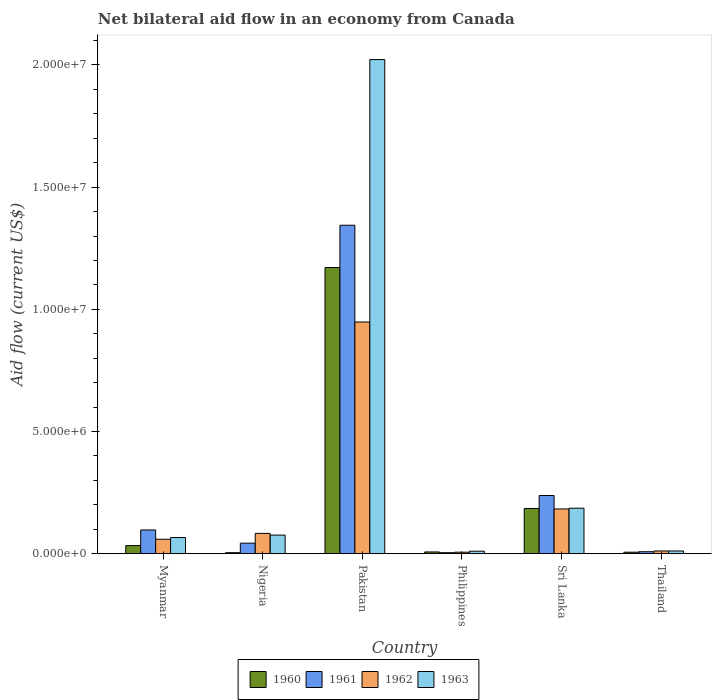How many groups of bars are there?
Make the answer very short. 6. How many bars are there on the 2nd tick from the left?
Make the answer very short. 4. What is the label of the 5th group of bars from the left?
Offer a terse response. Sri Lanka. Across all countries, what is the maximum net bilateral aid flow in 1960?
Your response must be concise. 1.17e+07. What is the total net bilateral aid flow in 1963 in the graph?
Your answer should be very brief. 2.37e+07. What is the difference between the net bilateral aid flow in 1961 in Nigeria and the net bilateral aid flow in 1962 in Sri Lanka?
Offer a terse response. -1.40e+06. What is the average net bilateral aid flow in 1960 per country?
Ensure brevity in your answer.  2.34e+06. What is the difference between the net bilateral aid flow of/in 1962 and net bilateral aid flow of/in 1960 in Philippines?
Provide a short and direct response. -10000. In how many countries, is the net bilateral aid flow in 1963 greater than 10000000 US$?
Keep it short and to the point. 1. What is the ratio of the net bilateral aid flow in 1962 in Nigeria to that in Sri Lanka?
Your answer should be very brief. 0.45. Is the net bilateral aid flow in 1963 in Philippines less than that in Thailand?
Your answer should be very brief. Yes. What is the difference between the highest and the second highest net bilateral aid flow in 1960?
Ensure brevity in your answer.  1.14e+07. What is the difference between the highest and the lowest net bilateral aid flow in 1963?
Provide a short and direct response. 2.01e+07. In how many countries, is the net bilateral aid flow in 1961 greater than the average net bilateral aid flow in 1961 taken over all countries?
Offer a terse response. 1. Is it the case that in every country, the sum of the net bilateral aid flow in 1961 and net bilateral aid flow in 1962 is greater than the sum of net bilateral aid flow in 1963 and net bilateral aid flow in 1960?
Your response must be concise. No. Are all the bars in the graph horizontal?
Provide a succinct answer. No. How many countries are there in the graph?
Give a very brief answer. 6. Are the values on the major ticks of Y-axis written in scientific E-notation?
Offer a terse response. Yes. Does the graph contain any zero values?
Offer a very short reply. No. Does the graph contain grids?
Your answer should be very brief. No. Where does the legend appear in the graph?
Offer a terse response. Bottom center. What is the title of the graph?
Your response must be concise. Net bilateral aid flow in an economy from Canada. Does "1972" appear as one of the legend labels in the graph?
Provide a succinct answer. No. What is the label or title of the X-axis?
Provide a short and direct response. Country. What is the Aid flow (current US$) in 1960 in Myanmar?
Offer a terse response. 3.30e+05. What is the Aid flow (current US$) in 1961 in Myanmar?
Your response must be concise. 9.70e+05. What is the Aid flow (current US$) in 1962 in Myanmar?
Provide a succinct answer. 5.90e+05. What is the Aid flow (current US$) of 1960 in Nigeria?
Keep it short and to the point. 4.00e+04. What is the Aid flow (current US$) in 1962 in Nigeria?
Your response must be concise. 8.30e+05. What is the Aid flow (current US$) in 1963 in Nigeria?
Make the answer very short. 7.60e+05. What is the Aid flow (current US$) of 1960 in Pakistan?
Offer a very short reply. 1.17e+07. What is the Aid flow (current US$) in 1961 in Pakistan?
Keep it short and to the point. 1.34e+07. What is the Aid flow (current US$) of 1962 in Pakistan?
Offer a terse response. 9.48e+06. What is the Aid flow (current US$) in 1963 in Pakistan?
Keep it short and to the point. 2.02e+07. What is the Aid flow (current US$) in 1961 in Philippines?
Give a very brief answer. 4.00e+04. What is the Aid flow (current US$) in 1960 in Sri Lanka?
Offer a very short reply. 1.85e+06. What is the Aid flow (current US$) of 1961 in Sri Lanka?
Your answer should be very brief. 2.38e+06. What is the Aid flow (current US$) in 1962 in Sri Lanka?
Offer a terse response. 1.83e+06. What is the Aid flow (current US$) of 1963 in Sri Lanka?
Give a very brief answer. 1.86e+06. What is the Aid flow (current US$) in 1960 in Thailand?
Ensure brevity in your answer.  6.00e+04. What is the Aid flow (current US$) in 1963 in Thailand?
Offer a very short reply. 1.10e+05. Across all countries, what is the maximum Aid flow (current US$) in 1960?
Offer a terse response. 1.17e+07. Across all countries, what is the maximum Aid flow (current US$) of 1961?
Offer a terse response. 1.34e+07. Across all countries, what is the maximum Aid flow (current US$) in 1962?
Your answer should be compact. 9.48e+06. Across all countries, what is the maximum Aid flow (current US$) of 1963?
Provide a short and direct response. 2.02e+07. Across all countries, what is the minimum Aid flow (current US$) in 1962?
Offer a terse response. 6.00e+04. Across all countries, what is the minimum Aid flow (current US$) of 1963?
Make the answer very short. 1.00e+05. What is the total Aid flow (current US$) in 1960 in the graph?
Provide a short and direct response. 1.41e+07. What is the total Aid flow (current US$) in 1961 in the graph?
Keep it short and to the point. 1.73e+07. What is the total Aid flow (current US$) of 1962 in the graph?
Ensure brevity in your answer.  1.29e+07. What is the total Aid flow (current US$) in 1963 in the graph?
Offer a terse response. 2.37e+07. What is the difference between the Aid flow (current US$) in 1961 in Myanmar and that in Nigeria?
Give a very brief answer. 5.40e+05. What is the difference between the Aid flow (current US$) in 1960 in Myanmar and that in Pakistan?
Your answer should be compact. -1.14e+07. What is the difference between the Aid flow (current US$) in 1961 in Myanmar and that in Pakistan?
Make the answer very short. -1.25e+07. What is the difference between the Aid flow (current US$) of 1962 in Myanmar and that in Pakistan?
Your answer should be compact. -8.89e+06. What is the difference between the Aid flow (current US$) of 1963 in Myanmar and that in Pakistan?
Give a very brief answer. -1.96e+07. What is the difference between the Aid flow (current US$) in 1960 in Myanmar and that in Philippines?
Give a very brief answer. 2.60e+05. What is the difference between the Aid flow (current US$) of 1961 in Myanmar and that in Philippines?
Ensure brevity in your answer.  9.30e+05. What is the difference between the Aid flow (current US$) in 1962 in Myanmar and that in Philippines?
Offer a very short reply. 5.30e+05. What is the difference between the Aid flow (current US$) of 1963 in Myanmar and that in Philippines?
Ensure brevity in your answer.  5.60e+05. What is the difference between the Aid flow (current US$) of 1960 in Myanmar and that in Sri Lanka?
Make the answer very short. -1.52e+06. What is the difference between the Aid flow (current US$) in 1961 in Myanmar and that in Sri Lanka?
Ensure brevity in your answer.  -1.41e+06. What is the difference between the Aid flow (current US$) of 1962 in Myanmar and that in Sri Lanka?
Provide a succinct answer. -1.24e+06. What is the difference between the Aid flow (current US$) of 1963 in Myanmar and that in Sri Lanka?
Give a very brief answer. -1.20e+06. What is the difference between the Aid flow (current US$) of 1961 in Myanmar and that in Thailand?
Ensure brevity in your answer.  8.90e+05. What is the difference between the Aid flow (current US$) of 1962 in Myanmar and that in Thailand?
Keep it short and to the point. 4.80e+05. What is the difference between the Aid flow (current US$) of 1960 in Nigeria and that in Pakistan?
Provide a succinct answer. -1.17e+07. What is the difference between the Aid flow (current US$) in 1961 in Nigeria and that in Pakistan?
Provide a short and direct response. -1.30e+07. What is the difference between the Aid flow (current US$) in 1962 in Nigeria and that in Pakistan?
Offer a very short reply. -8.65e+06. What is the difference between the Aid flow (current US$) in 1963 in Nigeria and that in Pakistan?
Ensure brevity in your answer.  -1.95e+07. What is the difference between the Aid flow (current US$) in 1960 in Nigeria and that in Philippines?
Give a very brief answer. -3.00e+04. What is the difference between the Aid flow (current US$) in 1962 in Nigeria and that in Philippines?
Give a very brief answer. 7.70e+05. What is the difference between the Aid flow (current US$) of 1960 in Nigeria and that in Sri Lanka?
Your answer should be very brief. -1.81e+06. What is the difference between the Aid flow (current US$) in 1961 in Nigeria and that in Sri Lanka?
Your response must be concise. -1.95e+06. What is the difference between the Aid flow (current US$) of 1963 in Nigeria and that in Sri Lanka?
Ensure brevity in your answer.  -1.10e+06. What is the difference between the Aid flow (current US$) of 1960 in Nigeria and that in Thailand?
Your response must be concise. -2.00e+04. What is the difference between the Aid flow (current US$) in 1961 in Nigeria and that in Thailand?
Your answer should be very brief. 3.50e+05. What is the difference between the Aid flow (current US$) of 1962 in Nigeria and that in Thailand?
Ensure brevity in your answer.  7.20e+05. What is the difference between the Aid flow (current US$) in 1963 in Nigeria and that in Thailand?
Provide a succinct answer. 6.50e+05. What is the difference between the Aid flow (current US$) of 1960 in Pakistan and that in Philippines?
Make the answer very short. 1.16e+07. What is the difference between the Aid flow (current US$) in 1961 in Pakistan and that in Philippines?
Offer a terse response. 1.34e+07. What is the difference between the Aid flow (current US$) in 1962 in Pakistan and that in Philippines?
Provide a succinct answer. 9.42e+06. What is the difference between the Aid flow (current US$) of 1963 in Pakistan and that in Philippines?
Give a very brief answer. 2.01e+07. What is the difference between the Aid flow (current US$) in 1960 in Pakistan and that in Sri Lanka?
Ensure brevity in your answer.  9.86e+06. What is the difference between the Aid flow (current US$) of 1961 in Pakistan and that in Sri Lanka?
Provide a short and direct response. 1.11e+07. What is the difference between the Aid flow (current US$) in 1962 in Pakistan and that in Sri Lanka?
Give a very brief answer. 7.65e+06. What is the difference between the Aid flow (current US$) in 1963 in Pakistan and that in Sri Lanka?
Your answer should be very brief. 1.84e+07. What is the difference between the Aid flow (current US$) in 1960 in Pakistan and that in Thailand?
Offer a terse response. 1.16e+07. What is the difference between the Aid flow (current US$) in 1961 in Pakistan and that in Thailand?
Keep it short and to the point. 1.34e+07. What is the difference between the Aid flow (current US$) of 1962 in Pakistan and that in Thailand?
Offer a very short reply. 9.37e+06. What is the difference between the Aid flow (current US$) of 1963 in Pakistan and that in Thailand?
Your answer should be compact. 2.01e+07. What is the difference between the Aid flow (current US$) in 1960 in Philippines and that in Sri Lanka?
Your response must be concise. -1.78e+06. What is the difference between the Aid flow (current US$) of 1961 in Philippines and that in Sri Lanka?
Offer a terse response. -2.34e+06. What is the difference between the Aid flow (current US$) in 1962 in Philippines and that in Sri Lanka?
Provide a succinct answer. -1.77e+06. What is the difference between the Aid flow (current US$) in 1963 in Philippines and that in Sri Lanka?
Your answer should be compact. -1.76e+06. What is the difference between the Aid flow (current US$) of 1961 in Philippines and that in Thailand?
Your answer should be very brief. -4.00e+04. What is the difference between the Aid flow (current US$) in 1962 in Philippines and that in Thailand?
Give a very brief answer. -5.00e+04. What is the difference between the Aid flow (current US$) in 1963 in Philippines and that in Thailand?
Provide a short and direct response. -10000. What is the difference between the Aid flow (current US$) in 1960 in Sri Lanka and that in Thailand?
Make the answer very short. 1.79e+06. What is the difference between the Aid flow (current US$) in 1961 in Sri Lanka and that in Thailand?
Provide a short and direct response. 2.30e+06. What is the difference between the Aid flow (current US$) of 1962 in Sri Lanka and that in Thailand?
Ensure brevity in your answer.  1.72e+06. What is the difference between the Aid flow (current US$) of 1963 in Sri Lanka and that in Thailand?
Ensure brevity in your answer.  1.75e+06. What is the difference between the Aid flow (current US$) in 1960 in Myanmar and the Aid flow (current US$) in 1961 in Nigeria?
Your response must be concise. -1.00e+05. What is the difference between the Aid flow (current US$) in 1960 in Myanmar and the Aid flow (current US$) in 1962 in Nigeria?
Your answer should be compact. -5.00e+05. What is the difference between the Aid flow (current US$) in 1960 in Myanmar and the Aid flow (current US$) in 1963 in Nigeria?
Your answer should be very brief. -4.30e+05. What is the difference between the Aid flow (current US$) of 1960 in Myanmar and the Aid flow (current US$) of 1961 in Pakistan?
Keep it short and to the point. -1.31e+07. What is the difference between the Aid flow (current US$) of 1960 in Myanmar and the Aid flow (current US$) of 1962 in Pakistan?
Your response must be concise. -9.15e+06. What is the difference between the Aid flow (current US$) in 1960 in Myanmar and the Aid flow (current US$) in 1963 in Pakistan?
Give a very brief answer. -1.99e+07. What is the difference between the Aid flow (current US$) of 1961 in Myanmar and the Aid flow (current US$) of 1962 in Pakistan?
Keep it short and to the point. -8.51e+06. What is the difference between the Aid flow (current US$) of 1961 in Myanmar and the Aid flow (current US$) of 1963 in Pakistan?
Offer a very short reply. -1.92e+07. What is the difference between the Aid flow (current US$) in 1962 in Myanmar and the Aid flow (current US$) in 1963 in Pakistan?
Provide a succinct answer. -1.96e+07. What is the difference between the Aid flow (current US$) of 1960 in Myanmar and the Aid flow (current US$) of 1961 in Philippines?
Give a very brief answer. 2.90e+05. What is the difference between the Aid flow (current US$) in 1960 in Myanmar and the Aid flow (current US$) in 1963 in Philippines?
Your answer should be compact. 2.30e+05. What is the difference between the Aid flow (current US$) of 1961 in Myanmar and the Aid flow (current US$) of 1962 in Philippines?
Your answer should be compact. 9.10e+05. What is the difference between the Aid flow (current US$) in 1961 in Myanmar and the Aid flow (current US$) in 1963 in Philippines?
Give a very brief answer. 8.70e+05. What is the difference between the Aid flow (current US$) of 1960 in Myanmar and the Aid flow (current US$) of 1961 in Sri Lanka?
Your answer should be very brief. -2.05e+06. What is the difference between the Aid flow (current US$) of 1960 in Myanmar and the Aid flow (current US$) of 1962 in Sri Lanka?
Provide a short and direct response. -1.50e+06. What is the difference between the Aid flow (current US$) of 1960 in Myanmar and the Aid flow (current US$) of 1963 in Sri Lanka?
Provide a succinct answer. -1.53e+06. What is the difference between the Aid flow (current US$) of 1961 in Myanmar and the Aid flow (current US$) of 1962 in Sri Lanka?
Provide a short and direct response. -8.60e+05. What is the difference between the Aid flow (current US$) in 1961 in Myanmar and the Aid flow (current US$) in 1963 in Sri Lanka?
Give a very brief answer. -8.90e+05. What is the difference between the Aid flow (current US$) of 1962 in Myanmar and the Aid flow (current US$) of 1963 in Sri Lanka?
Ensure brevity in your answer.  -1.27e+06. What is the difference between the Aid flow (current US$) of 1960 in Myanmar and the Aid flow (current US$) of 1961 in Thailand?
Give a very brief answer. 2.50e+05. What is the difference between the Aid flow (current US$) in 1960 in Myanmar and the Aid flow (current US$) in 1962 in Thailand?
Your answer should be very brief. 2.20e+05. What is the difference between the Aid flow (current US$) in 1961 in Myanmar and the Aid flow (current US$) in 1962 in Thailand?
Your answer should be very brief. 8.60e+05. What is the difference between the Aid flow (current US$) of 1961 in Myanmar and the Aid flow (current US$) of 1963 in Thailand?
Give a very brief answer. 8.60e+05. What is the difference between the Aid flow (current US$) in 1962 in Myanmar and the Aid flow (current US$) in 1963 in Thailand?
Your answer should be compact. 4.80e+05. What is the difference between the Aid flow (current US$) in 1960 in Nigeria and the Aid flow (current US$) in 1961 in Pakistan?
Your response must be concise. -1.34e+07. What is the difference between the Aid flow (current US$) of 1960 in Nigeria and the Aid flow (current US$) of 1962 in Pakistan?
Provide a succinct answer. -9.44e+06. What is the difference between the Aid flow (current US$) in 1960 in Nigeria and the Aid flow (current US$) in 1963 in Pakistan?
Your answer should be compact. -2.02e+07. What is the difference between the Aid flow (current US$) of 1961 in Nigeria and the Aid flow (current US$) of 1962 in Pakistan?
Provide a succinct answer. -9.05e+06. What is the difference between the Aid flow (current US$) of 1961 in Nigeria and the Aid flow (current US$) of 1963 in Pakistan?
Make the answer very short. -1.98e+07. What is the difference between the Aid flow (current US$) in 1962 in Nigeria and the Aid flow (current US$) in 1963 in Pakistan?
Provide a succinct answer. -1.94e+07. What is the difference between the Aid flow (current US$) of 1960 in Nigeria and the Aid flow (current US$) of 1963 in Philippines?
Provide a succinct answer. -6.00e+04. What is the difference between the Aid flow (current US$) of 1961 in Nigeria and the Aid flow (current US$) of 1962 in Philippines?
Your answer should be compact. 3.70e+05. What is the difference between the Aid flow (current US$) in 1961 in Nigeria and the Aid flow (current US$) in 1963 in Philippines?
Provide a succinct answer. 3.30e+05. What is the difference between the Aid flow (current US$) of 1962 in Nigeria and the Aid flow (current US$) of 1963 in Philippines?
Offer a very short reply. 7.30e+05. What is the difference between the Aid flow (current US$) in 1960 in Nigeria and the Aid flow (current US$) in 1961 in Sri Lanka?
Your response must be concise. -2.34e+06. What is the difference between the Aid flow (current US$) of 1960 in Nigeria and the Aid flow (current US$) of 1962 in Sri Lanka?
Make the answer very short. -1.79e+06. What is the difference between the Aid flow (current US$) in 1960 in Nigeria and the Aid flow (current US$) in 1963 in Sri Lanka?
Ensure brevity in your answer.  -1.82e+06. What is the difference between the Aid flow (current US$) of 1961 in Nigeria and the Aid flow (current US$) of 1962 in Sri Lanka?
Offer a terse response. -1.40e+06. What is the difference between the Aid flow (current US$) of 1961 in Nigeria and the Aid flow (current US$) of 1963 in Sri Lanka?
Your answer should be very brief. -1.43e+06. What is the difference between the Aid flow (current US$) in 1962 in Nigeria and the Aid flow (current US$) in 1963 in Sri Lanka?
Ensure brevity in your answer.  -1.03e+06. What is the difference between the Aid flow (current US$) of 1960 in Nigeria and the Aid flow (current US$) of 1961 in Thailand?
Your answer should be very brief. -4.00e+04. What is the difference between the Aid flow (current US$) of 1960 in Nigeria and the Aid flow (current US$) of 1963 in Thailand?
Your answer should be very brief. -7.00e+04. What is the difference between the Aid flow (current US$) of 1962 in Nigeria and the Aid flow (current US$) of 1963 in Thailand?
Your answer should be very brief. 7.20e+05. What is the difference between the Aid flow (current US$) of 1960 in Pakistan and the Aid flow (current US$) of 1961 in Philippines?
Give a very brief answer. 1.17e+07. What is the difference between the Aid flow (current US$) of 1960 in Pakistan and the Aid flow (current US$) of 1962 in Philippines?
Provide a succinct answer. 1.16e+07. What is the difference between the Aid flow (current US$) of 1960 in Pakistan and the Aid flow (current US$) of 1963 in Philippines?
Offer a very short reply. 1.16e+07. What is the difference between the Aid flow (current US$) of 1961 in Pakistan and the Aid flow (current US$) of 1962 in Philippines?
Ensure brevity in your answer.  1.34e+07. What is the difference between the Aid flow (current US$) of 1961 in Pakistan and the Aid flow (current US$) of 1963 in Philippines?
Your response must be concise. 1.33e+07. What is the difference between the Aid flow (current US$) in 1962 in Pakistan and the Aid flow (current US$) in 1963 in Philippines?
Provide a short and direct response. 9.38e+06. What is the difference between the Aid flow (current US$) in 1960 in Pakistan and the Aid flow (current US$) in 1961 in Sri Lanka?
Provide a succinct answer. 9.33e+06. What is the difference between the Aid flow (current US$) of 1960 in Pakistan and the Aid flow (current US$) of 1962 in Sri Lanka?
Your answer should be very brief. 9.88e+06. What is the difference between the Aid flow (current US$) of 1960 in Pakistan and the Aid flow (current US$) of 1963 in Sri Lanka?
Your answer should be very brief. 9.85e+06. What is the difference between the Aid flow (current US$) of 1961 in Pakistan and the Aid flow (current US$) of 1962 in Sri Lanka?
Offer a very short reply. 1.16e+07. What is the difference between the Aid flow (current US$) in 1961 in Pakistan and the Aid flow (current US$) in 1963 in Sri Lanka?
Provide a succinct answer. 1.16e+07. What is the difference between the Aid flow (current US$) in 1962 in Pakistan and the Aid flow (current US$) in 1963 in Sri Lanka?
Provide a succinct answer. 7.62e+06. What is the difference between the Aid flow (current US$) of 1960 in Pakistan and the Aid flow (current US$) of 1961 in Thailand?
Your answer should be very brief. 1.16e+07. What is the difference between the Aid flow (current US$) in 1960 in Pakistan and the Aid flow (current US$) in 1962 in Thailand?
Give a very brief answer. 1.16e+07. What is the difference between the Aid flow (current US$) of 1960 in Pakistan and the Aid flow (current US$) of 1963 in Thailand?
Ensure brevity in your answer.  1.16e+07. What is the difference between the Aid flow (current US$) of 1961 in Pakistan and the Aid flow (current US$) of 1962 in Thailand?
Provide a succinct answer. 1.33e+07. What is the difference between the Aid flow (current US$) of 1961 in Pakistan and the Aid flow (current US$) of 1963 in Thailand?
Your response must be concise. 1.33e+07. What is the difference between the Aid flow (current US$) in 1962 in Pakistan and the Aid flow (current US$) in 1963 in Thailand?
Offer a very short reply. 9.37e+06. What is the difference between the Aid flow (current US$) of 1960 in Philippines and the Aid flow (current US$) of 1961 in Sri Lanka?
Offer a terse response. -2.31e+06. What is the difference between the Aid flow (current US$) in 1960 in Philippines and the Aid flow (current US$) in 1962 in Sri Lanka?
Give a very brief answer. -1.76e+06. What is the difference between the Aid flow (current US$) of 1960 in Philippines and the Aid flow (current US$) of 1963 in Sri Lanka?
Offer a very short reply. -1.79e+06. What is the difference between the Aid flow (current US$) of 1961 in Philippines and the Aid flow (current US$) of 1962 in Sri Lanka?
Your answer should be very brief. -1.79e+06. What is the difference between the Aid flow (current US$) of 1961 in Philippines and the Aid flow (current US$) of 1963 in Sri Lanka?
Make the answer very short. -1.82e+06. What is the difference between the Aid flow (current US$) in 1962 in Philippines and the Aid flow (current US$) in 1963 in Sri Lanka?
Make the answer very short. -1.80e+06. What is the difference between the Aid flow (current US$) in 1960 in Philippines and the Aid flow (current US$) in 1961 in Thailand?
Make the answer very short. -10000. What is the difference between the Aid flow (current US$) in 1960 in Philippines and the Aid flow (current US$) in 1963 in Thailand?
Your answer should be compact. -4.00e+04. What is the difference between the Aid flow (current US$) of 1960 in Sri Lanka and the Aid flow (current US$) of 1961 in Thailand?
Provide a succinct answer. 1.77e+06. What is the difference between the Aid flow (current US$) of 1960 in Sri Lanka and the Aid flow (current US$) of 1962 in Thailand?
Give a very brief answer. 1.74e+06. What is the difference between the Aid flow (current US$) of 1960 in Sri Lanka and the Aid flow (current US$) of 1963 in Thailand?
Give a very brief answer. 1.74e+06. What is the difference between the Aid flow (current US$) of 1961 in Sri Lanka and the Aid flow (current US$) of 1962 in Thailand?
Provide a succinct answer. 2.27e+06. What is the difference between the Aid flow (current US$) of 1961 in Sri Lanka and the Aid flow (current US$) of 1963 in Thailand?
Your answer should be compact. 2.27e+06. What is the difference between the Aid flow (current US$) of 1962 in Sri Lanka and the Aid flow (current US$) of 1963 in Thailand?
Offer a terse response. 1.72e+06. What is the average Aid flow (current US$) in 1960 per country?
Make the answer very short. 2.34e+06. What is the average Aid flow (current US$) in 1961 per country?
Give a very brief answer. 2.89e+06. What is the average Aid flow (current US$) in 1962 per country?
Ensure brevity in your answer.  2.15e+06. What is the average Aid flow (current US$) in 1963 per country?
Your response must be concise. 3.95e+06. What is the difference between the Aid flow (current US$) in 1960 and Aid flow (current US$) in 1961 in Myanmar?
Keep it short and to the point. -6.40e+05. What is the difference between the Aid flow (current US$) of 1960 and Aid flow (current US$) of 1963 in Myanmar?
Make the answer very short. -3.30e+05. What is the difference between the Aid flow (current US$) of 1961 and Aid flow (current US$) of 1962 in Myanmar?
Make the answer very short. 3.80e+05. What is the difference between the Aid flow (current US$) in 1962 and Aid flow (current US$) in 1963 in Myanmar?
Your answer should be very brief. -7.00e+04. What is the difference between the Aid flow (current US$) in 1960 and Aid flow (current US$) in 1961 in Nigeria?
Give a very brief answer. -3.90e+05. What is the difference between the Aid flow (current US$) of 1960 and Aid flow (current US$) of 1962 in Nigeria?
Provide a short and direct response. -7.90e+05. What is the difference between the Aid flow (current US$) in 1960 and Aid flow (current US$) in 1963 in Nigeria?
Ensure brevity in your answer.  -7.20e+05. What is the difference between the Aid flow (current US$) in 1961 and Aid flow (current US$) in 1962 in Nigeria?
Give a very brief answer. -4.00e+05. What is the difference between the Aid flow (current US$) of 1961 and Aid flow (current US$) of 1963 in Nigeria?
Offer a very short reply. -3.30e+05. What is the difference between the Aid flow (current US$) of 1960 and Aid flow (current US$) of 1961 in Pakistan?
Your answer should be compact. -1.73e+06. What is the difference between the Aid flow (current US$) of 1960 and Aid flow (current US$) of 1962 in Pakistan?
Offer a terse response. 2.23e+06. What is the difference between the Aid flow (current US$) of 1960 and Aid flow (current US$) of 1963 in Pakistan?
Your answer should be compact. -8.51e+06. What is the difference between the Aid flow (current US$) of 1961 and Aid flow (current US$) of 1962 in Pakistan?
Your answer should be very brief. 3.96e+06. What is the difference between the Aid flow (current US$) of 1961 and Aid flow (current US$) of 1963 in Pakistan?
Your answer should be very brief. -6.78e+06. What is the difference between the Aid flow (current US$) of 1962 and Aid flow (current US$) of 1963 in Pakistan?
Your answer should be very brief. -1.07e+07. What is the difference between the Aid flow (current US$) of 1960 and Aid flow (current US$) of 1961 in Philippines?
Give a very brief answer. 3.00e+04. What is the difference between the Aid flow (current US$) in 1960 and Aid flow (current US$) in 1963 in Philippines?
Your answer should be very brief. -3.00e+04. What is the difference between the Aid flow (current US$) of 1961 and Aid flow (current US$) of 1962 in Philippines?
Your answer should be very brief. -2.00e+04. What is the difference between the Aid flow (current US$) of 1960 and Aid flow (current US$) of 1961 in Sri Lanka?
Your answer should be compact. -5.30e+05. What is the difference between the Aid flow (current US$) of 1960 and Aid flow (current US$) of 1962 in Sri Lanka?
Your answer should be very brief. 2.00e+04. What is the difference between the Aid flow (current US$) in 1961 and Aid flow (current US$) in 1962 in Sri Lanka?
Your answer should be very brief. 5.50e+05. What is the difference between the Aid flow (current US$) of 1961 and Aid flow (current US$) of 1963 in Sri Lanka?
Your response must be concise. 5.20e+05. What is the difference between the Aid flow (current US$) of 1962 and Aid flow (current US$) of 1963 in Sri Lanka?
Give a very brief answer. -3.00e+04. What is the difference between the Aid flow (current US$) of 1960 and Aid flow (current US$) of 1961 in Thailand?
Your answer should be compact. -2.00e+04. What is the difference between the Aid flow (current US$) in 1960 and Aid flow (current US$) in 1963 in Thailand?
Keep it short and to the point. -5.00e+04. What is the ratio of the Aid flow (current US$) of 1960 in Myanmar to that in Nigeria?
Make the answer very short. 8.25. What is the ratio of the Aid flow (current US$) of 1961 in Myanmar to that in Nigeria?
Make the answer very short. 2.26. What is the ratio of the Aid flow (current US$) in 1962 in Myanmar to that in Nigeria?
Your answer should be very brief. 0.71. What is the ratio of the Aid flow (current US$) in 1963 in Myanmar to that in Nigeria?
Ensure brevity in your answer.  0.87. What is the ratio of the Aid flow (current US$) of 1960 in Myanmar to that in Pakistan?
Offer a very short reply. 0.03. What is the ratio of the Aid flow (current US$) in 1961 in Myanmar to that in Pakistan?
Offer a terse response. 0.07. What is the ratio of the Aid flow (current US$) in 1962 in Myanmar to that in Pakistan?
Give a very brief answer. 0.06. What is the ratio of the Aid flow (current US$) in 1963 in Myanmar to that in Pakistan?
Make the answer very short. 0.03. What is the ratio of the Aid flow (current US$) of 1960 in Myanmar to that in Philippines?
Your answer should be compact. 4.71. What is the ratio of the Aid flow (current US$) of 1961 in Myanmar to that in Philippines?
Your response must be concise. 24.25. What is the ratio of the Aid flow (current US$) of 1962 in Myanmar to that in Philippines?
Make the answer very short. 9.83. What is the ratio of the Aid flow (current US$) of 1963 in Myanmar to that in Philippines?
Offer a terse response. 6.6. What is the ratio of the Aid flow (current US$) of 1960 in Myanmar to that in Sri Lanka?
Provide a succinct answer. 0.18. What is the ratio of the Aid flow (current US$) in 1961 in Myanmar to that in Sri Lanka?
Your response must be concise. 0.41. What is the ratio of the Aid flow (current US$) in 1962 in Myanmar to that in Sri Lanka?
Provide a succinct answer. 0.32. What is the ratio of the Aid flow (current US$) in 1963 in Myanmar to that in Sri Lanka?
Give a very brief answer. 0.35. What is the ratio of the Aid flow (current US$) of 1960 in Myanmar to that in Thailand?
Your answer should be very brief. 5.5. What is the ratio of the Aid flow (current US$) in 1961 in Myanmar to that in Thailand?
Offer a very short reply. 12.12. What is the ratio of the Aid flow (current US$) of 1962 in Myanmar to that in Thailand?
Offer a terse response. 5.36. What is the ratio of the Aid flow (current US$) in 1963 in Myanmar to that in Thailand?
Offer a very short reply. 6. What is the ratio of the Aid flow (current US$) in 1960 in Nigeria to that in Pakistan?
Give a very brief answer. 0. What is the ratio of the Aid flow (current US$) of 1961 in Nigeria to that in Pakistan?
Offer a very short reply. 0.03. What is the ratio of the Aid flow (current US$) of 1962 in Nigeria to that in Pakistan?
Your answer should be compact. 0.09. What is the ratio of the Aid flow (current US$) in 1963 in Nigeria to that in Pakistan?
Give a very brief answer. 0.04. What is the ratio of the Aid flow (current US$) in 1960 in Nigeria to that in Philippines?
Provide a succinct answer. 0.57. What is the ratio of the Aid flow (current US$) in 1961 in Nigeria to that in Philippines?
Offer a very short reply. 10.75. What is the ratio of the Aid flow (current US$) of 1962 in Nigeria to that in Philippines?
Keep it short and to the point. 13.83. What is the ratio of the Aid flow (current US$) of 1963 in Nigeria to that in Philippines?
Make the answer very short. 7.6. What is the ratio of the Aid flow (current US$) of 1960 in Nigeria to that in Sri Lanka?
Offer a terse response. 0.02. What is the ratio of the Aid flow (current US$) in 1961 in Nigeria to that in Sri Lanka?
Keep it short and to the point. 0.18. What is the ratio of the Aid flow (current US$) in 1962 in Nigeria to that in Sri Lanka?
Offer a terse response. 0.45. What is the ratio of the Aid flow (current US$) of 1963 in Nigeria to that in Sri Lanka?
Provide a short and direct response. 0.41. What is the ratio of the Aid flow (current US$) in 1960 in Nigeria to that in Thailand?
Provide a succinct answer. 0.67. What is the ratio of the Aid flow (current US$) of 1961 in Nigeria to that in Thailand?
Offer a terse response. 5.38. What is the ratio of the Aid flow (current US$) in 1962 in Nigeria to that in Thailand?
Ensure brevity in your answer.  7.55. What is the ratio of the Aid flow (current US$) of 1963 in Nigeria to that in Thailand?
Make the answer very short. 6.91. What is the ratio of the Aid flow (current US$) in 1960 in Pakistan to that in Philippines?
Your response must be concise. 167.29. What is the ratio of the Aid flow (current US$) in 1961 in Pakistan to that in Philippines?
Provide a succinct answer. 336. What is the ratio of the Aid flow (current US$) of 1962 in Pakistan to that in Philippines?
Give a very brief answer. 158. What is the ratio of the Aid flow (current US$) in 1963 in Pakistan to that in Philippines?
Offer a terse response. 202.2. What is the ratio of the Aid flow (current US$) in 1960 in Pakistan to that in Sri Lanka?
Provide a succinct answer. 6.33. What is the ratio of the Aid flow (current US$) in 1961 in Pakistan to that in Sri Lanka?
Keep it short and to the point. 5.65. What is the ratio of the Aid flow (current US$) of 1962 in Pakistan to that in Sri Lanka?
Your answer should be compact. 5.18. What is the ratio of the Aid flow (current US$) of 1963 in Pakistan to that in Sri Lanka?
Your response must be concise. 10.87. What is the ratio of the Aid flow (current US$) in 1960 in Pakistan to that in Thailand?
Make the answer very short. 195.17. What is the ratio of the Aid flow (current US$) of 1961 in Pakistan to that in Thailand?
Provide a succinct answer. 168. What is the ratio of the Aid flow (current US$) in 1962 in Pakistan to that in Thailand?
Your answer should be compact. 86.18. What is the ratio of the Aid flow (current US$) in 1963 in Pakistan to that in Thailand?
Offer a very short reply. 183.82. What is the ratio of the Aid flow (current US$) of 1960 in Philippines to that in Sri Lanka?
Provide a succinct answer. 0.04. What is the ratio of the Aid flow (current US$) of 1961 in Philippines to that in Sri Lanka?
Give a very brief answer. 0.02. What is the ratio of the Aid flow (current US$) in 1962 in Philippines to that in Sri Lanka?
Ensure brevity in your answer.  0.03. What is the ratio of the Aid flow (current US$) in 1963 in Philippines to that in Sri Lanka?
Provide a succinct answer. 0.05. What is the ratio of the Aid flow (current US$) in 1960 in Philippines to that in Thailand?
Offer a terse response. 1.17. What is the ratio of the Aid flow (current US$) of 1961 in Philippines to that in Thailand?
Your answer should be compact. 0.5. What is the ratio of the Aid flow (current US$) in 1962 in Philippines to that in Thailand?
Keep it short and to the point. 0.55. What is the ratio of the Aid flow (current US$) of 1963 in Philippines to that in Thailand?
Offer a very short reply. 0.91. What is the ratio of the Aid flow (current US$) of 1960 in Sri Lanka to that in Thailand?
Your response must be concise. 30.83. What is the ratio of the Aid flow (current US$) of 1961 in Sri Lanka to that in Thailand?
Your answer should be very brief. 29.75. What is the ratio of the Aid flow (current US$) of 1962 in Sri Lanka to that in Thailand?
Offer a very short reply. 16.64. What is the ratio of the Aid flow (current US$) of 1963 in Sri Lanka to that in Thailand?
Your response must be concise. 16.91. What is the difference between the highest and the second highest Aid flow (current US$) of 1960?
Provide a short and direct response. 9.86e+06. What is the difference between the highest and the second highest Aid flow (current US$) in 1961?
Give a very brief answer. 1.11e+07. What is the difference between the highest and the second highest Aid flow (current US$) in 1962?
Ensure brevity in your answer.  7.65e+06. What is the difference between the highest and the second highest Aid flow (current US$) of 1963?
Offer a very short reply. 1.84e+07. What is the difference between the highest and the lowest Aid flow (current US$) in 1960?
Your answer should be very brief. 1.17e+07. What is the difference between the highest and the lowest Aid flow (current US$) of 1961?
Ensure brevity in your answer.  1.34e+07. What is the difference between the highest and the lowest Aid flow (current US$) in 1962?
Keep it short and to the point. 9.42e+06. What is the difference between the highest and the lowest Aid flow (current US$) in 1963?
Make the answer very short. 2.01e+07. 